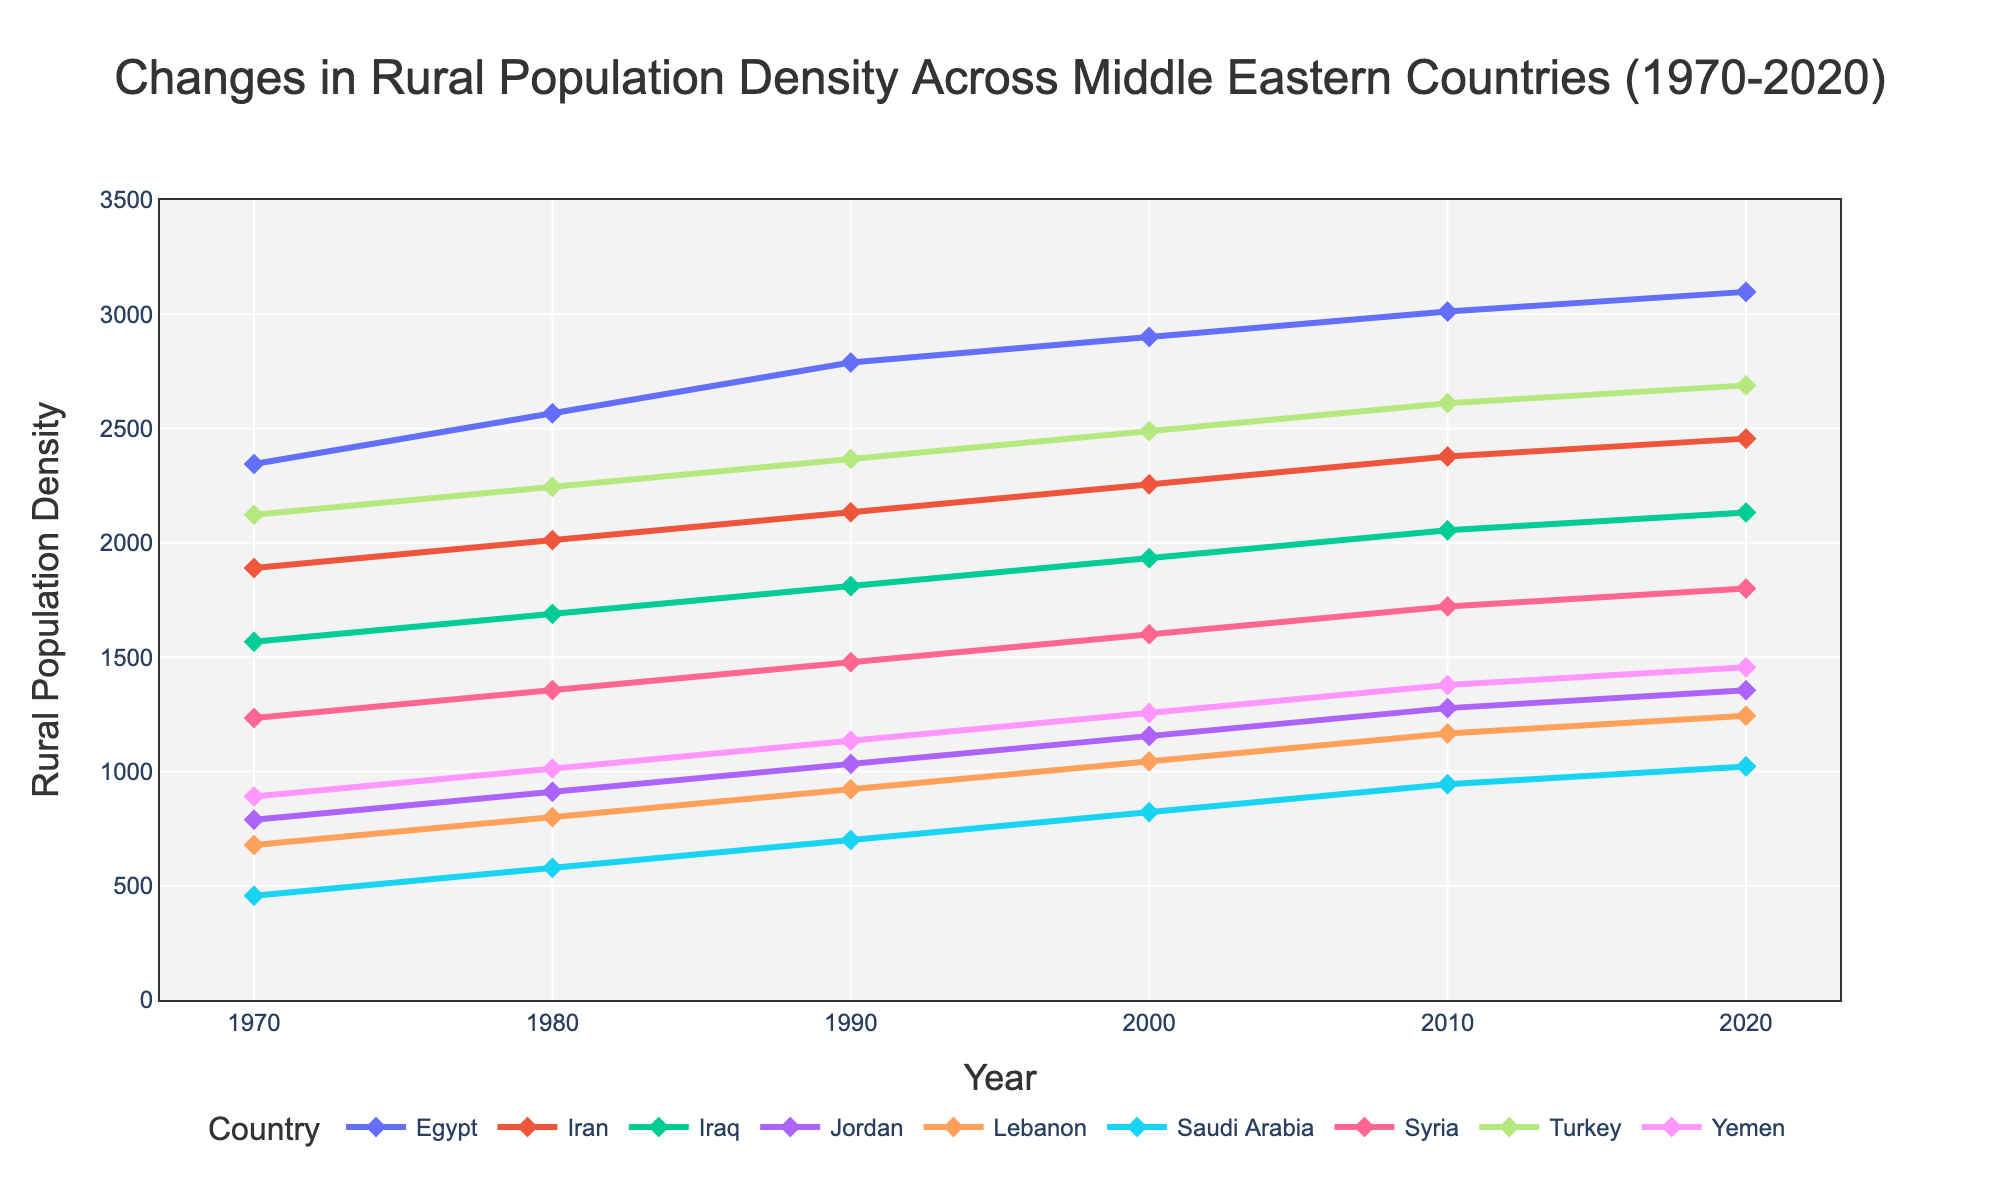what is the average rural population density of Turkey between 1970 and 2020? To find the average, we need to sum up the rural population densities of Turkey for the years 1970, 1980, 1990, 2000, 2010, and 2020, and then divide by the number of years. Sum: 2123 + 2245 + 2367 + 2489 + 2611 + 2689 = 14524. The number of years is 6. Thus, average = 14524 / 6 = 2420.67
Answer: 2420.67 Between Egypt and Iran, which country has a higher rural population density in 1980? Look at the values for Egypt and Iran in 1980. Egypt's rural population density in 1980 is 2567, while Iran's is 2012. Since 2567 is greater than 2012, Egypt has a higher rural population density in 1980.
Answer: Egypt Which country had the lowest rural population density in 2020? Examine the rural population densities for all countries listed in 2020. The values are: Egypt - 3098, Iran - 2456, Iraq - 2133, Jordan - 1355, Lebanon - 1244, Saudi Arabia - 1022, Syria - 1800, Turkey - 2689, Yemen - 1456. The lowest density is for Saudi Arabia (1022).
Answer: Saudi Arabia How does the trend of rural population density from 1970 to 2020 compare between Lebanon and Yemen? Observe the lines for Lebanon and Yemen from 1970 to 2020. Lebanon's rural population density increased from 678 to 1244, while Yemen's increased from 890 to 1456. Both countries show an overall increasing trend, but Yemen's densities are consistently higher than Lebanon's throughout the period.
Answer: Both increased, Yemen higher Which country shows the most consistent increase in rural population density over the years? Look for the country whose line on the plot shows the most steady and consistent upward trend. Without significant fluctuations or declines, Turkey and Egypt appear to have consistent increases in rural population density from 1970 to 2020, but Turkey has a steadier trend.
Answer: Turkey What is the difference in rural population density between Syria and Iraq in 2020? Note the rural population densities for Syria and Iraq in 2020. Syria's density is 1800, while Iraq's is 2133. The difference is 2133 - 1800 = 333.
Answer: 333 What is the total rural population density across all countries in 2010? Sum up the rural population densities of all countries for 2010. The values are: Egypt - 3012, Iran - 2378, Iraq - 2055, Jordan - 1277, Lebanon - 1166, Saudi Arabia - 944, Syria - 1722, Turkey - 2611, Yemen - 1378. Total: 3012 + 2378 + 2055 + 1277 + 1166 + 944 + 1722 + 2611 + 1378 = 17043.
Answer: 17043 